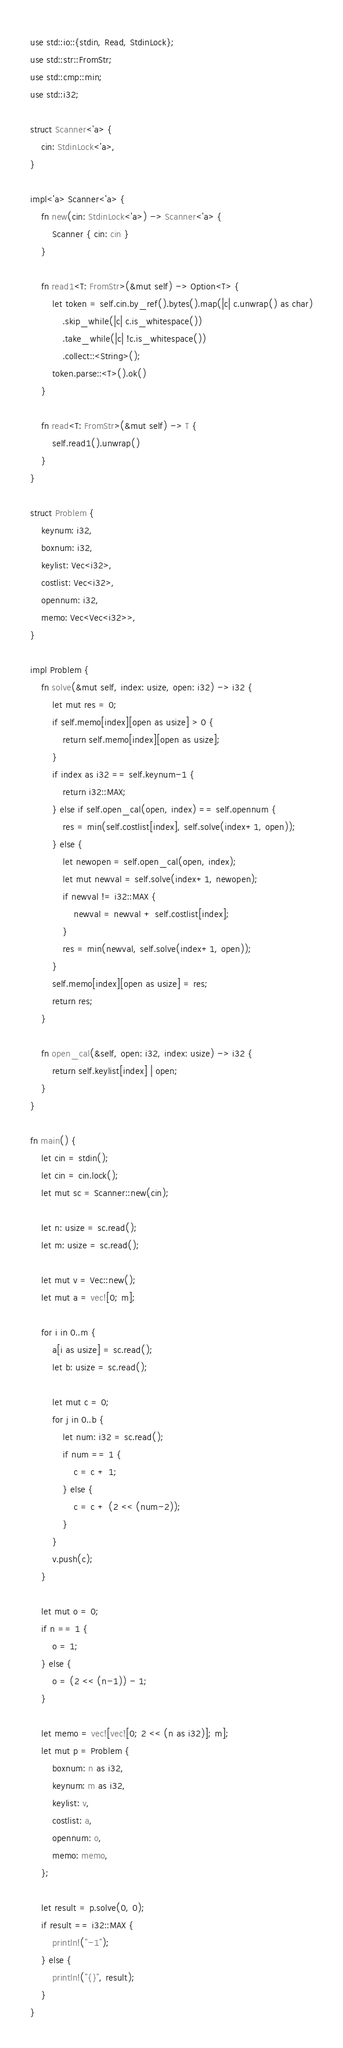<code> <loc_0><loc_0><loc_500><loc_500><_Rust_>use std::io::{stdin, Read, StdinLock};
use std::str::FromStr;
use std::cmp::min;
use std::i32;

struct Scanner<'a> {
    cin: StdinLock<'a>,
}
 
impl<'a> Scanner<'a> {
    fn new(cin: StdinLock<'a>) -> Scanner<'a> {
        Scanner { cin: cin }
    }
 
    fn read1<T: FromStr>(&mut self) -> Option<T> {
        let token = self.cin.by_ref().bytes().map(|c| c.unwrap() as char)
            .skip_while(|c| c.is_whitespace())
            .take_while(|c| !c.is_whitespace())
            .collect::<String>();
        token.parse::<T>().ok()
    }
 
    fn read<T: FromStr>(&mut self) -> T {
        self.read1().unwrap()
    }
}

struct Problem {
    keynum: i32,
    boxnum: i32,
    keylist: Vec<i32>,
    costlist: Vec<i32>,
    opennum: i32,
    memo: Vec<Vec<i32>>,
}

impl Problem {
    fn solve(&mut self, index: usize, open: i32) -> i32 {
        let mut res = 0;
        if self.memo[index][open as usize] > 0 {
            return self.memo[index][open as usize];
        }
        if index as i32 == self.keynum-1 {
            return i32::MAX;
        } else if self.open_cal(open, index) == self.opennum {
            res = min(self.costlist[index], self.solve(index+1, open));
        } else {
            let newopen = self.open_cal(open, index);
            let mut newval = self.solve(index+1, newopen);
            if newval != i32::MAX {
                newval = newval + self.costlist[index];
            }
            res = min(newval, self.solve(index+1, open));
        }
        self.memo[index][open as usize] = res;
        return res;
    }

    fn open_cal(&self, open: i32, index: usize) -> i32 {
        return self.keylist[index] | open;
    }
}

fn main() {
    let cin = stdin();
    let cin = cin.lock();
    let mut sc = Scanner::new(cin);

    let n: usize = sc.read();
    let m: usize = sc.read();

    let mut v = Vec::new();
    let mut a = vec![0; m];

    for i in 0..m {
        a[i as usize] = sc.read();
        let b: usize = sc.read();

        let mut c = 0;
        for j in 0..b {
            let num: i32 = sc.read();
            if num == 1 {
                c = c + 1;
            } else {
                c = c + (2 << (num-2));
            }
        }
        v.push(c);
    }

    let mut o = 0;
    if n == 1 {
        o = 1;
    } else {
        o = (2 << (n-1)) - 1;
    }

    let memo = vec![vec![0; 2 << (n as i32)]; m];
    let mut p = Problem {
        boxnum: n as i32,
        keynum: m as i32,
        keylist: v,
        costlist: a,
        opennum: o,
        memo: memo,
    };

    let result = p.solve(0, 0);
    if result == i32::MAX {
        println!("-1");
    } else {
        println!("{}", result);
    }
}</code> 